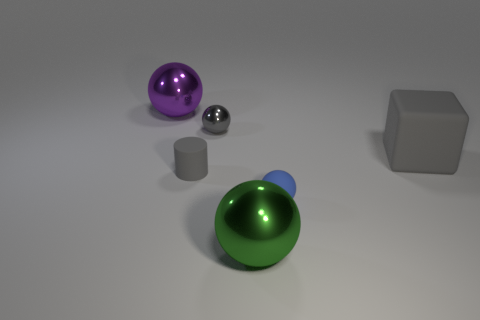Is there a object of the same color as the small rubber sphere?
Provide a succinct answer. No. Is there a green shiny ball that is in front of the big metal object in front of the big purple shiny ball?
Keep it short and to the point. No. Do the green thing and the gray object right of the large green metal ball have the same size?
Provide a short and direct response. Yes. There is a gray matte object right of the large metallic object that is to the right of the small rubber cylinder; is there a small rubber ball that is behind it?
Your answer should be very brief. No. There is a tiny gray object that is right of the small gray cylinder; what is it made of?
Your response must be concise. Metal. Is the gray matte cylinder the same size as the purple thing?
Ensure brevity in your answer.  No. There is a object that is behind the large block and left of the gray ball; what is its color?
Provide a succinct answer. Purple. There is a large thing that is the same material as the tiny blue ball; what is its shape?
Your answer should be compact. Cube. How many small objects are in front of the small metal object and right of the small matte cylinder?
Give a very brief answer. 1. Are there any gray things behind the tiny shiny object?
Keep it short and to the point. No. 